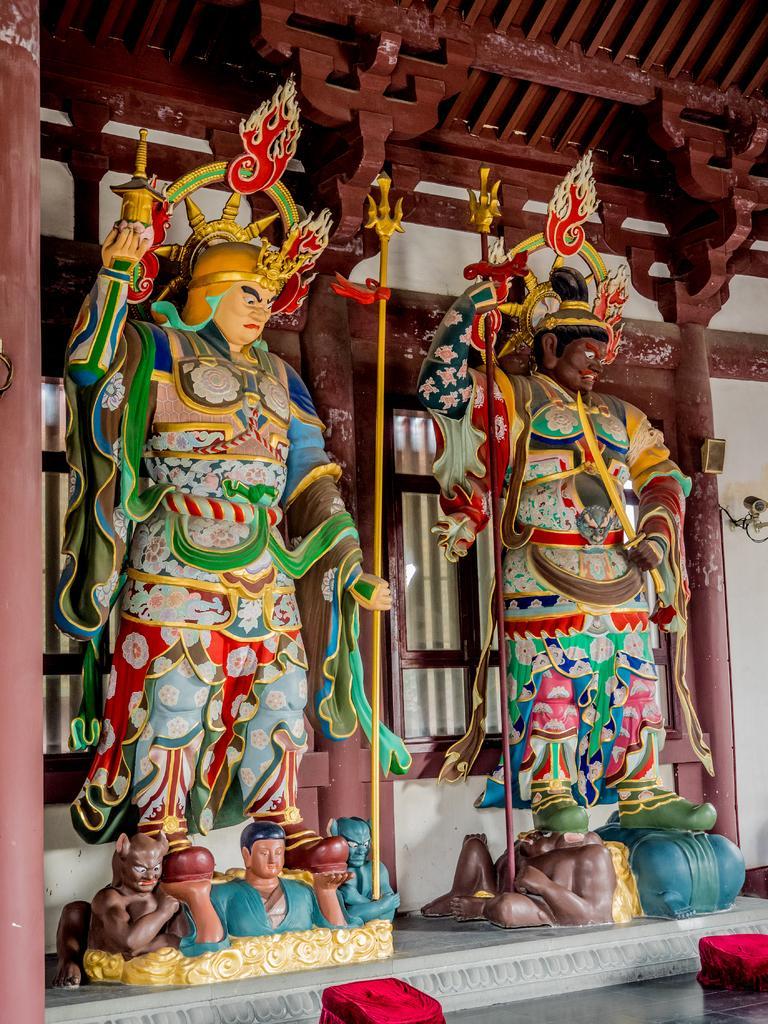Can you describe this image briefly? We can see statues and pillars. Behind statues we can see wall and windows. 